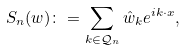<formula> <loc_0><loc_0><loc_500><loc_500>S _ { n } ( w ) \colon = \sum _ { k \in \mathcal { Q } _ { n } } \hat { w } _ { k } e ^ { i k \cdot x } ,</formula> 